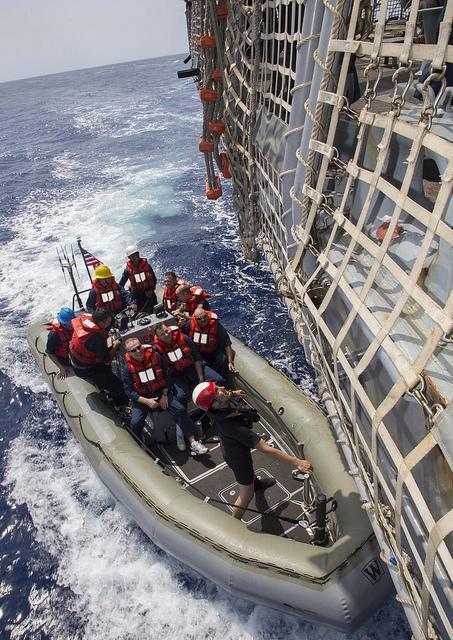How many people are in the picture?
Give a very brief answer. 3. 